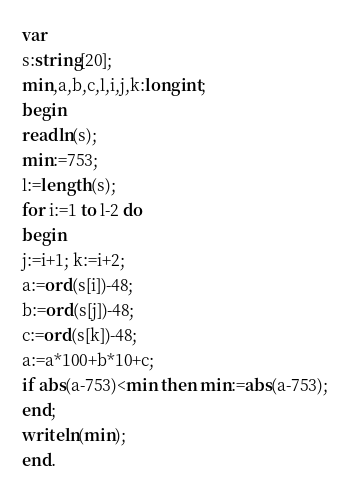Convert code to text. <code><loc_0><loc_0><loc_500><loc_500><_Pascal_>var
s:string[20];
min,a,b,c,l,i,j,k:longint;
begin
readln(s);
min:=753;
l:=length(s);
for i:=1 to l-2 do
begin
j:=i+1; k:=i+2;
a:=ord(s[i])-48;
b:=ord(s[j])-48;
c:=ord(s[k])-48;
a:=a*100+b*10+c;
if abs(a-753)<min then min:=abs(a-753);
end;
writeln(min);
end.
</code> 